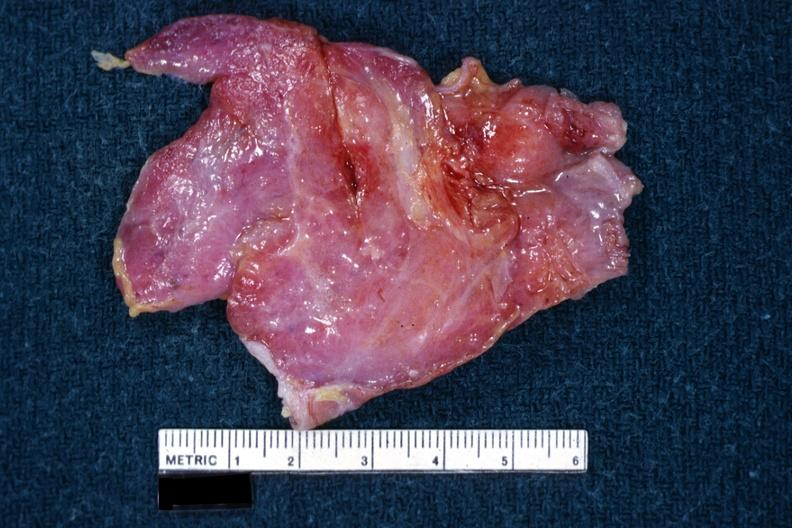s this a thymus?
Answer the question using a single word or phrase. Yes 